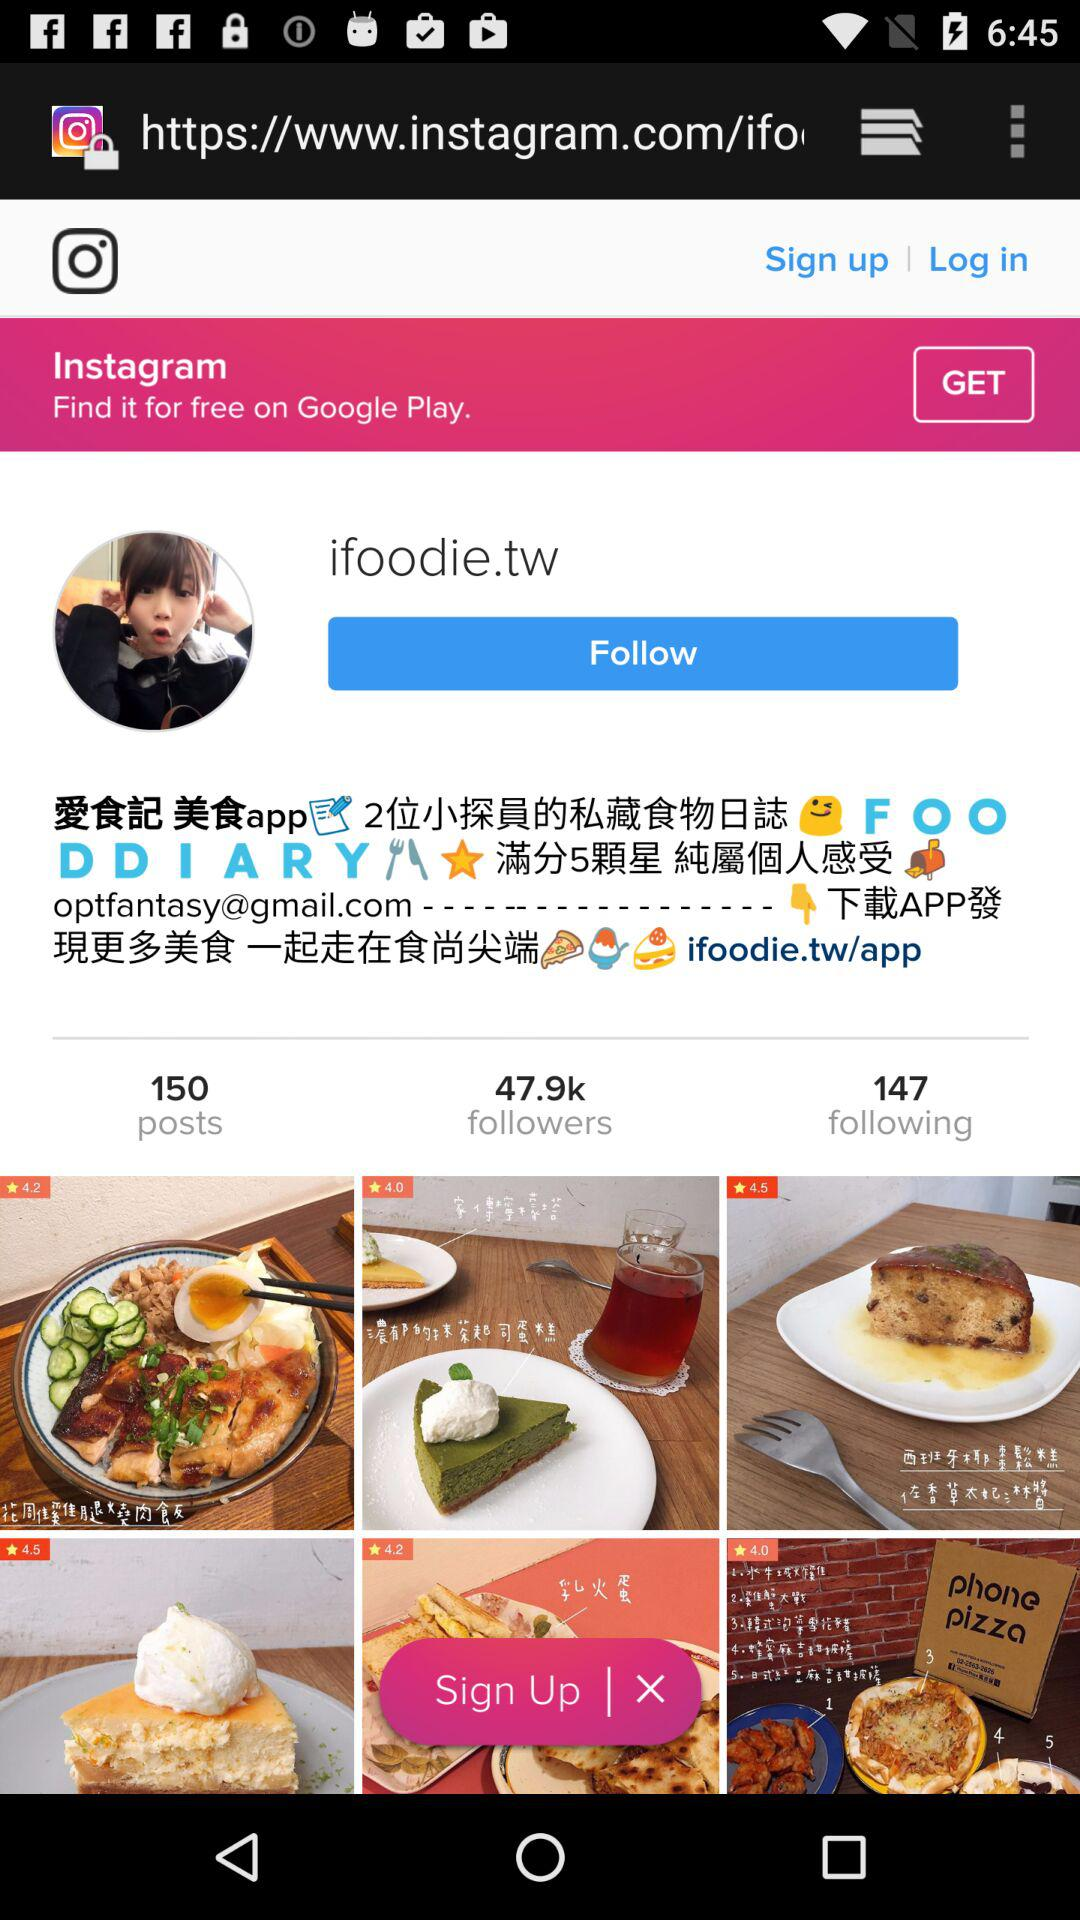What is the Instagram page name? The Instagram page name is "ifoodie.tw". 